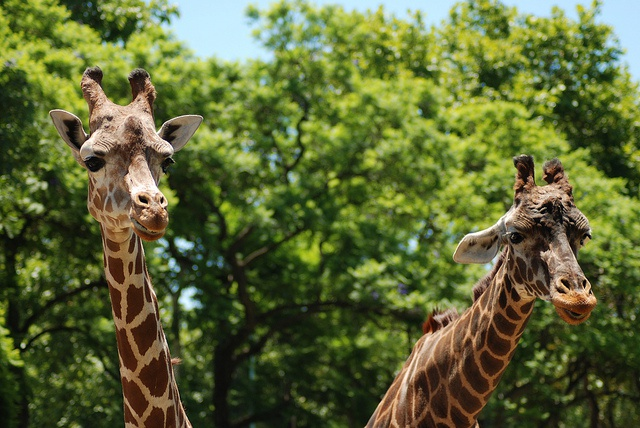Describe the objects in this image and their specific colors. I can see giraffe in black, maroon, and gray tones and giraffe in black, gray, maroon, and olive tones in this image. 